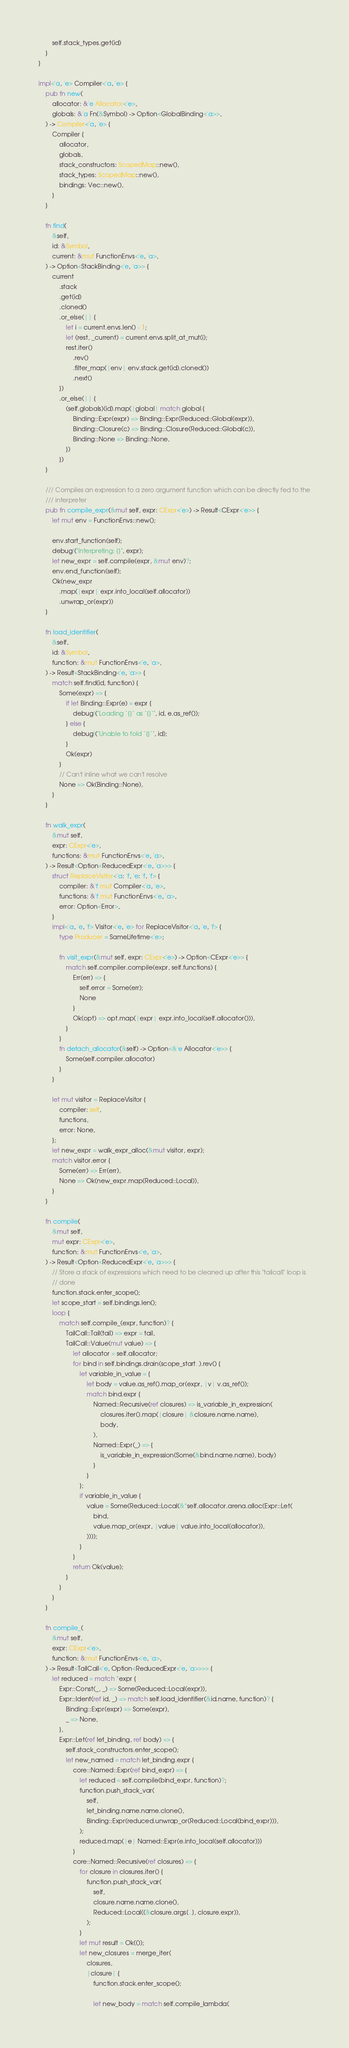Convert code to text. <code><loc_0><loc_0><loc_500><loc_500><_Rust_>        self.stack_types.get(id)
    }
}

impl<'a, 'e> Compiler<'a, 'e> {
    pub fn new(
        allocator: &'e Allocator<'e>,
        globals: &'a Fn(&Symbol) -> Option<GlobalBinding<'a>>,
    ) -> Compiler<'a, 'e> {
        Compiler {
            allocator,
            globals,
            stack_constructors: ScopedMap::new(),
            stack_types: ScopedMap::new(),
            bindings: Vec::new(),
        }
    }

    fn find(
        &self,
        id: &Symbol,
        current: &mut FunctionEnvs<'e, 'a>,
    ) -> Option<StackBinding<'e, 'a>> {
        current
            .stack
            .get(id)
            .cloned()
            .or_else(|| {
                let i = current.envs.len() - 1;
                let (rest, _current) = current.envs.split_at_mut(i);
                rest.iter()
                    .rev()
                    .filter_map(|env| env.stack.get(id).cloned())
                    .next()
            })
            .or_else(|| {
                (self.globals)(id).map(|global| match global {
                    Binding::Expr(expr) => Binding::Expr(Reduced::Global(expr)),
                    Binding::Closure(c) => Binding::Closure(Reduced::Global(c)),
                    Binding::None => Binding::None,
                })
            })
    }

    /// Compiles an expression to a zero argument function which can be directly fed to the
    /// interpreter
    pub fn compile_expr(&mut self, expr: CExpr<'e>) -> Result<CExpr<'e>> {
        let mut env = FunctionEnvs::new();

        env.start_function(self);
        debug!("Interpreting: {}", expr);
        let new_expr = self.compile(expr, &mut env)?;
        env.end_function(self);
        Ok(new_expr
            .map(|expr| expr.into_local(self.allocator))
            .unwrap_or(expr))
    }

    fn load_identifier(
        &self,
        id: &Symbol,
        function: &mut FunctionEnvs<'e, 'a>,
    ) -> Result<StackBinding<'e, 'a>> {
        match self.find(id, function) {
            Some(expr) => {
                if let Binding::Expr(e) = expr {
                    debug!("Loading `{}` as `{}`", id, e.as_ref());
                } else {
                    debug!("Unable to fold `{}`", id);
                }
                Ok(expr)
            }
            // Can't inline what we can't resolve
            None => Ok(Binding::None),
        }
    }

    fn walk_expr(
        &mut self,
        expr: CExpr<'e>,
        functions: &mut FunctionEnvs<'e, 'a>,
    ) -> Result<Option<ReducedExpr<'e, 'a>>> {
        struct ReplaceVisitor<'a: 'f, 'e: 'f, 'f> {
            compiler: &'f mut Compiler<'a, 'e>,
            functions: &'f mut FunctionEnvs<'e, 'a>,
            error: Option<Error>,
        }
        impl<'a, 'e, 'f> Visitor<'e, 'e> for ReplaceVisitor<'a, 'e, 'f> {
            type Producer = SameLifetime<'e>;

            fn visit_expr(&mut self, expr: CExpr<'e>) -> Option<CExpr<'e>> {
                match self.compiler.compile(expr, self.functions) {
                    Err(err) => {
                        self.error = Some(err);
                        None
                    }
                    Ok(opt) => opt.map(|expr| expr.into_local(self.allocator())),
                }
            }
            fn detach_allocator(&self) -> Option<&'e Allocator<'e>> {
                Some(self.compiler.allocator)
            }
        }

        let mut visitor = ReplaceVisitor {
            compiler: self,
            functions,
            error: None,
        };
        let new_expr = walk_expr_alloc(&mut visitor, expr);
        match visitor.error {
            Some(err) => Err(err),
            None => Ok(new_expr.map(Reduced::Local)),
        }
    }

    fn compile(
        &mut self,
        mut expr: CExpr<'e>,
        function: &mut FunctionEnvs<'e, 'a>,
    ) -> Result<Option<ReducedExpr<'e, 'a>>> {
        // Store a stack of expressions which need to be cleaned up after this "tailcall" loop is
        // done
        function.stack.enter_scope();
        let scope_start = self.bindings.len();
        loop {
            match self.compile_(expr, function)? {
                TailCall::Tail(tail) => expr = tail,
                TailCall::Value(mut value) => {
                    let allocator = self.allocator;
                    for bind in self.bindings.drain(scope_start..).rev() {
                        let variable_in_value = {
                            let body = value.as_ref().map_or(expr, |v| v.as_ref());
                            match bind.expr {
                                Named::Recursive(ref closures) => is_variable_in_expression(
                                    closures.iter().map(|closure| &closure.name.name),
                                    body,
                                ),
                                Named::Expr(_) => {
                                    is_variable_in_expression(Some(&bind.name.name), body)
                                }
                            }
                        };
                        if variable_in_value {
                            value = Some(Reduced::Local(&*self.allocator.arena.alloc(Expr::Let(
                                bind,
                                value.map_or(expr, |value| value.into_local(allocator)),
                            ))));
                        }
                    }
                    return Ok(value);
                }
            }
        }
    }

    fn compile_(
        &mut self,
        expr: CExpr<'e>,
        function: &mut FunctionEnvs<'e, 'a>,
    ) -> Result<TailCall<'e, Option<ReducedExpr<'e, 'a>>>> {
        let reduced = match *expr {
            Expr::Const(_, _) => Some(Reduced::Local(expr)),
            Expr::Ident(ref id, _) => match self.load_identifier(&id.name, function)? {
                Binding::Expr(expr) => Some(expr),
                _ => None,
            },
            Expr::Let(ref let_binding, ref body) => {
                self.stack_constructors.enter_scope();
                let new_named = match let_binding.expr {
                    core::Named::Expr(ref bind_expr) => {
                        let reduced = self.compile(bind_expr, function)?;
                        function.push_stack_var(
                            self,
                            let_binding.name.name.clone(),
                            Binding::Expr(reduced.unwrap_or(Reduced::Local(bind_expr))),
                        );
                        reduced.map(|e| Named::Expr(e.into_local(self.allocator)))
                    }
                    core::Named::Recursive(ref closures) => {
                        for closure in closures.iter() {
                            function.push_stack_var(
                                self,
                                closure.name.name.clone(),
                                Reduced::Local((&closure.args[..], closure.expr)),
                            );
                        }
                        let mut result = Ok(());
                        let new_closures = merge_iter(
                            closures,
                            |closure| {
                                function.stack.enter_scope();

                                let new_body = match self.compile_lambda(</code> 